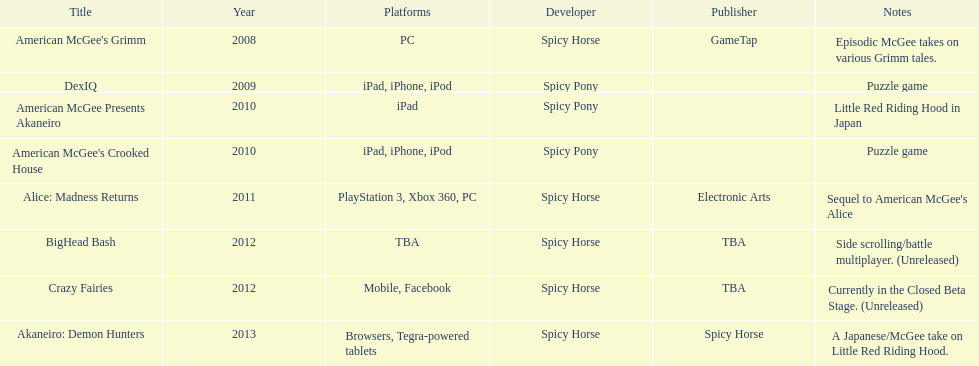What is the foremost caption on this graph? American McGee's Grimm. 